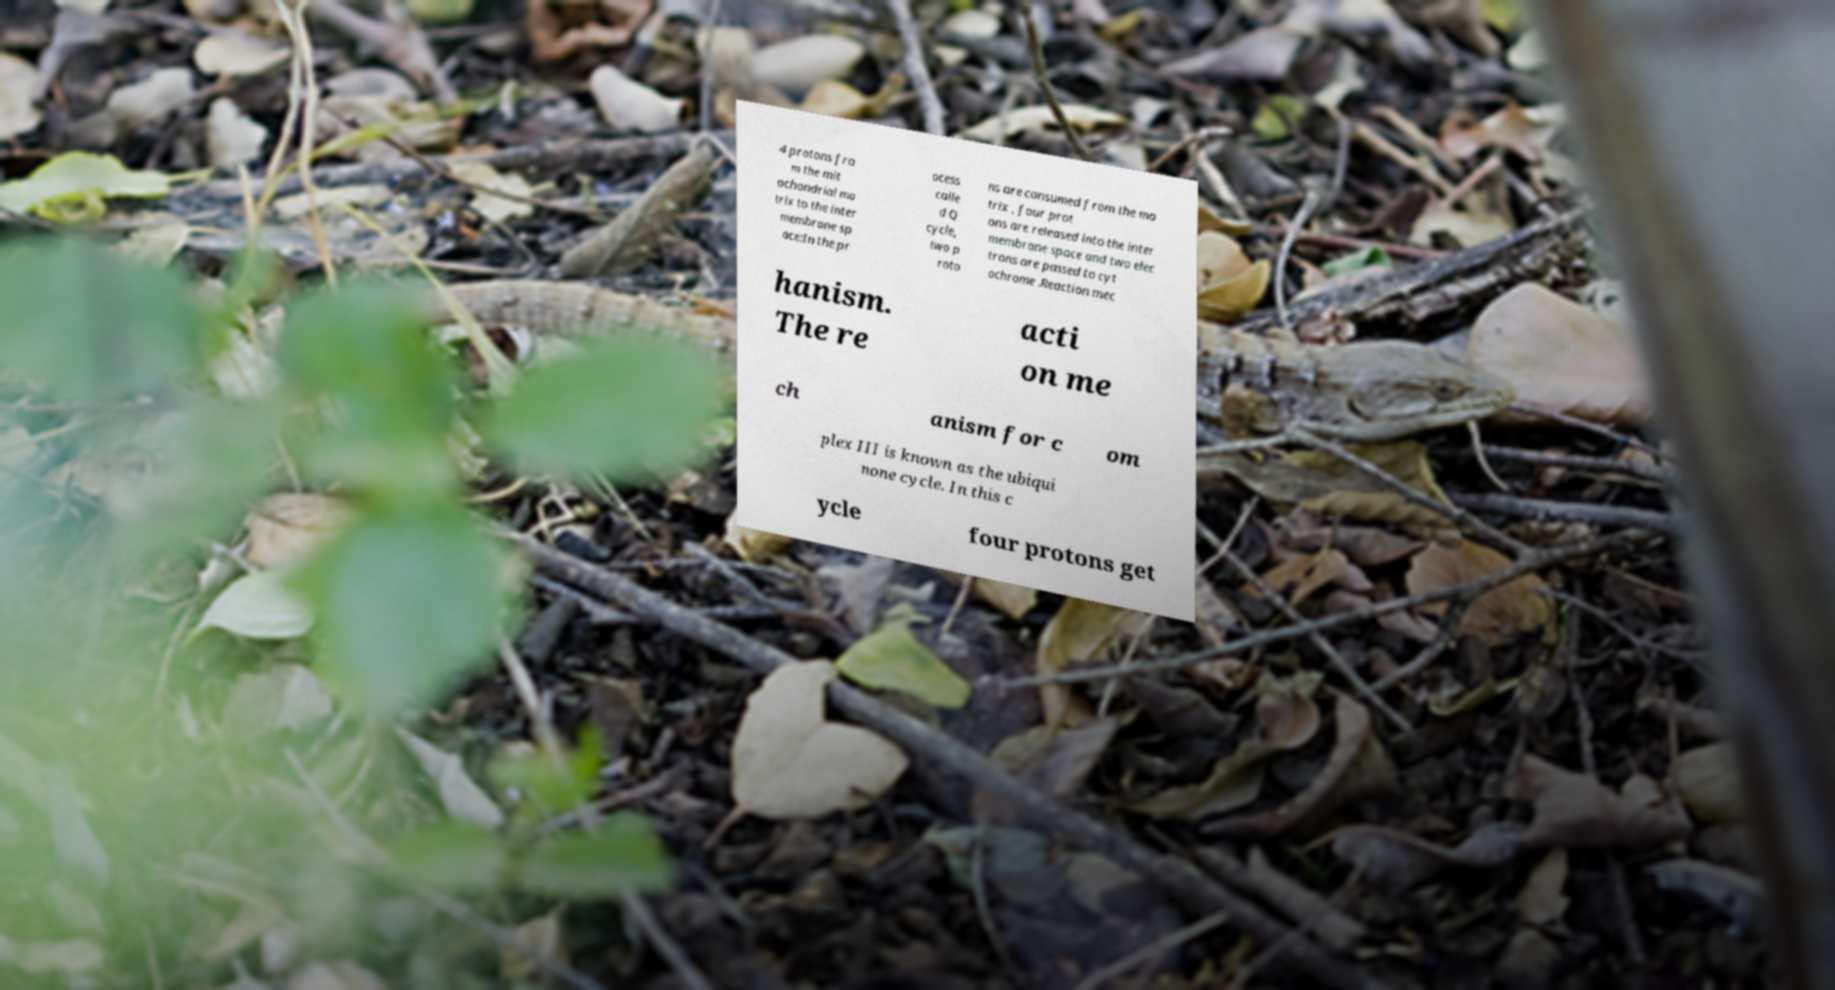For documentation purposes, I need the text within this image transcribed. Could you provide that? 4 protons fro m the mit ochondrial ma trix to the inter membrane sp ace:In the pr ocess calle d Q cycle, two p roto ns are consumed from the ma trix , four prot ons are released into the inter membrane space and two elec trons are passed to cyt ochrome .Reaction mec hanism. The re acti on me ch anism for c om plex III is known as the ubiqui none cycle. In this c ycle four protons get 